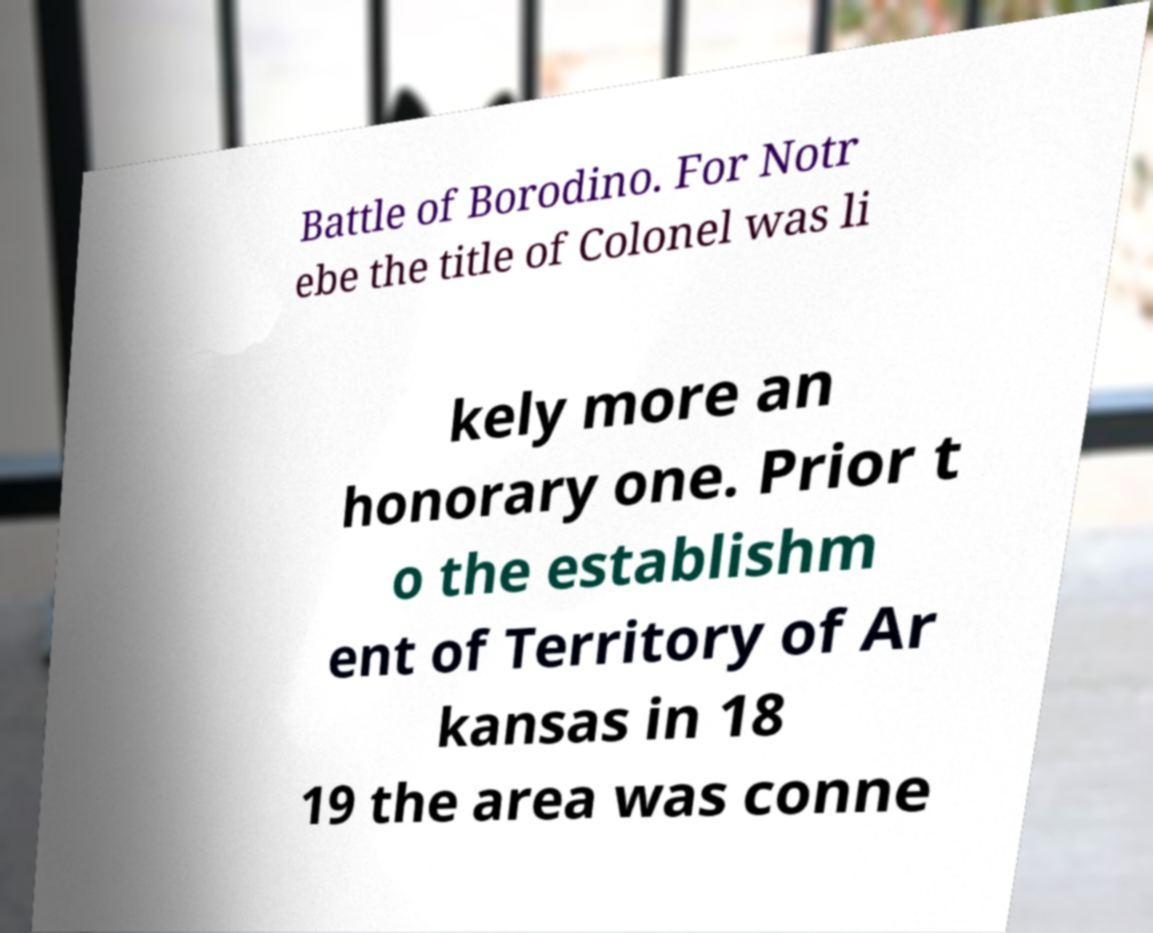Can you accurately transcribe the text from the provided image for me? Battle of Borodino. For Notr ebe the title of Colonel was li kely more an honorary one. Prior t o the establishm ent of Territory of Ar kansas in 18 19 the area was conne 